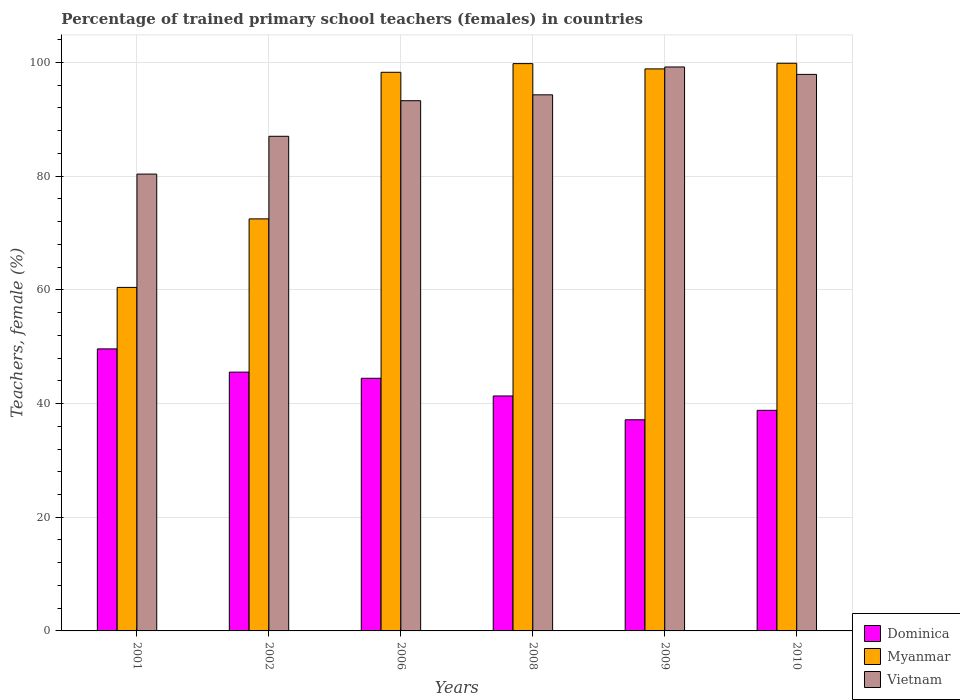How many bars are there on the 3rd tick from the right?
Your response must be concise. 3. What is the label of the 1st group of bars from the left?
Make the answer very short. 2001. What is the percentage of trained primary school teachers (females) in Myanmar in 2001?
Your answer should be compact. 60.43. Across all years, what is the maximum percentage of trained primary school teachers (females) in Myanmar?
Keep it short and to the point. 99.86. Across all years, what is the minimum percentage of trained primary school teachers (females) in Dominica?
Your answer should be compact. 37.14. In which year was the percentage of trained primary school teachers (females) in Dominica minimum?
Make the answer very short. 2009. What is the total percentage of trained primary school teachers (females) in Dominica in the graph?
Your answer should be compact. 256.87. What is the difference between the percentage of trained primary school teachers (females) in Myanmar in 2001 and that in 2006?
Ensure brevity in your answer.  -37.84. What is the difference between the percentage of trained primary school teachers (females) in Myanmar in 2010 and the percentage of trained primary school teachers (females) in Dominica in 2006?
Your answer should be very brief. 55.42. What is the average percentage of trained primary school teachers (females) in Myanmar per year?
Your answer should be compact. 88.29. In the year 2009, what is the difference between the percentage of trained primary school teachers (females) in Dominica and percentage of trained primary school teachers (females) in Vietnam?
Keep it short and to the point. -62.06. In how many years, is the percentage of trained primary school teachers (females) in Vietnam greater than 96 %?
Offer a very short reply. 2. What is the ratio of the percentage of trained primary school teachers (females) in Vietnam in 2001 to that in 2010?
Your response must be concise. 0.82. Is the difference between the percentage of trained primary school teachers (females) in Dominica in 2002 and 2008 greater than the difference between the percentage of trained primary school teachers (females) in Vietnam in 2002 and 2008?
Offer a terse response. Yes. What is the difference between the highest and the second highest percentage of trained primary school teachers (females) in Vietnam?
Your response must be concise. 1.31. What is the difference between the highest and the lowest percentage of trained primary school teachers (females) in Myanmar?
Ensure brevity in your answer.  39.43. Is the sum of the percentage of trained primary school teachers (females) in Myanmar in 2001 and 2006 greater than the maximum percentage of trained primary school teachers (females) in Vietnam across all years?
Offer a terse response. Yes. What does the 2nd bar from the left in 2006 represents?
Offer a terse response. Myanmar. What does the 1st bar from the right in 2009 represents?
Provide a short and direct response. Vietnam. Is it the case that in every year, the sum of the percentage of trained primary school teachers (females) in Myanmar and percentage of trained primary school teachers (females) in Dominica is greater than the percentage of trained primary school teachers (females) in Vietnam?
Give a very brief answer. Yes. How many bars are there?
Keep it short and to the point. 18. Does the graph contain any zero values?
Offer a very short reply. No. Where does the legend appear in the graph?
Ensure brevity in your answer.  Bottom right. How many legend labels are there?
Offer a terse response. 3. What is the title of the graph?
Your answer should be compact. Percentage of trained primary school teachers (females) in countries. Does "Maldives" appear as one of the legend labels in the graph?
Your answer should be very brief. No. What is the label or title of the X-axis?
Your answer should be very brief. Years. What is the label or title of the Y-axis?
Offer a very short reply. Teachers, female (%). What is the Teachers, female (%) in Dominica in 2001?
Offer a terse response. 49.61. What is the Teachers, female (%) of Myanmar in 2001?
Keep it short and to the point. 60.43. What is the Teachers, female (%) of Vietnam in 2001?
Your answer should be very brief. 80.37. What is the Teachers, female (%) in Dominica in 2002?
Ensure brevity in your answer.  45.53. What is the Teachers, female (%) in Myanmar in 2002?
Your answer should be compact. 72.48. What is the Teachers, female (%) of Vietnam in 2002?
Provide a succinct answer. 87.01. What is the Teachers, female (%) of Dominica in 2006?
Provide a short and direct response. 44.44. What is the Teachers, female (%) of Myanmar in 2006?
Offer a very short reply. 98.27. What is the Teachers, female (%) in Vietnam in 2006?
Your response must be concise. 93.27. What is the Teachers, female (%) of Dominica in 2008?
Offer a very short reply. 41.33. What is the Teachers, female (%) of Myanmar in 2008?
Give a very brief answer. 99.8. What is the Teachers, female (%) in Vietnam in 2008?
Make the answer very short. 94.31. What is the Teachers, female (%) in Dominica in 2009?
Keep it short and to the point. 37.14. What is the Teachers, female (%) in Myanmar in 2009?
Provide a short and direct response. 98.87. What is the Teachers, female (%) in Vietnam in 2009?
Provide a short and direct response. 99.21. What is the Teachers, female (%) in Dominica in 2010?
Provide a succinct answer. 38.81. What is the Teachers, female (%) of Myanmar in 2010?
Offer a terse response. 99.86. What is the Teachers, female (%) of Vietnam in 2010?
Provide a short and direct response. 97.9. Across all years, what is the maximum Teachers, female (%) in Dominica?
Your answer should be compact. 49.61. Across all years, what is the maximum Teachers, female (%) of Myanmar?
Your response must be concise. 99.86. Across all years, what is the maximum Teachers, female (%) in Vietnam?
Your response must be concise. 99.21. Across all years, what is the minimum Teachers, female (%) in Dominica?
Keep it short and to the point. 37.14. Across all years, what is the minimum Teachers, female (%) in Myanmar?
Provide a short and direct response. 60.43. Across all years, what is the minimum Teachers, female (%) in Vietnam?
Provide a succinct answer. 80.37. What is the total Teachers, female (%) in Dominica in the graph?
Keep it short and to the point. 256.87. What is the total Teachers, female (%) of Myanmar in the graph?
Keep it short and to the point. 529.71. What is the total Teachers, female (%) of Vietnam in the graph?
Ensure brevity in your answer.  552.06. What is the difference between the Teachers, female (%) in Dominica in 2001 and that in 2002?
Your response must be concise. 4.08. What is the difference between the Teachers, female (%) in Myanmar in 2001 and that in 2002?
Offer a terse response. -12.05. What is the difference between the Teachers, female (%) of Vietnam in 2001 and that in 2002?
Offer a very short reply. -6.65. What is the difference between the Teachers, female (%) in Dominica in 2001 and that in 2006?
Provide a short and direct response. 5.17. What is the difference between the Teachers, female (%) in Myanmar in 2001 and that in 2006?
Your answer should be compact. -37.84. What is the difference between the Teachers, female (%) in Vietnam in 2001 and that in 2006?
Give a very brief answer. -12.91. What is the difference between the Teachers, female (%) of Dominica in 2001 and that in 2008?
Keep it short and to the point. 8.28. What is the difference between the Teachers, female (%) of Myanmar in 2001 and that in 2008?
Make the answer very short. -39.37. What is the difference between the Teachers, female (%) in Vietnam in 2001 and that in 2008?
Give a very brief answer. -13.94. What is the difference between the Teachers, female (%) in Dominica in 2001 and that in 2009?
Ensure brevity in your answer.  12.47. What is the difference between the Teachers, female (%) in Myanmar in 2001 and that in 2009?
Your response must be concise. -38.44. What is the difference between the Teachers, female (%) of Vietnam in 2001 and that in 2009?
Give a very brief answer. -18.84. What is the difference between the Teachers, female (%) of Dominica in 2001 and that in 2010?
Give a very brief answer. 10.81. What is the difference between the Teachers, female (%) of Myanmar in 2001 and that in 2010?
Make the answer very short. -39.43. What is the difference between the Teachers, female (%) of Vietnam in 2001 and that in 2010?
Your response must be concise. -17.53. What is the difference between the Teachers, female (%) in Dominica in 2002 and that in 2006?
Your response must be concise. 1.08. What is the difference between the Teachers, female (%) of Myanmar in 2002 and that in 2006?
Give a very brief answer. -25.79. What is the difference between the Teachers, female (%) of Vietnam in 2002 and that in 2006?
Your response must be concise. -6.26. What is the difference between the Teachers, female (%) in Dominica in 2002 and that in 2008?
Ensure brevity in your answer.  4.2. What is the difference between the Teachers, female (%) of Myanmar in 2002 and that in 2008?
Offer a terse response. -27.31. What is the difference between the Teachers, female (%) of Vietnam in 2002 and that in 2008?
Give a very brief answer. -7.3. What is the difference between the Teachers, female (%) in Dominica in 2002 and that in 2009?
Provide a short and direct response. 8.39. What is the difference between the Teachers, female (%) in Myanmar in 2002 and that in 2009?
Ensure brevity in your answer.  -26.38. What is the difference between the Teachers, female (%) in Vietnam in 2002 and that in 2009?
Your answer should be very brief. -12.19. What is the difference between the Teachers, female (%) of Dominica in 2002 and that in 2010?
Your answer should be compact. 6.72. What is the difference between the Teachers, female (%) in Myanmar in 2002 and that in 2010?
Your answer should be very brief. -27.38. What is the difference between the Teachers, female (%) of Vietnam in 2002 and that in 2010?
Your response must be concise. -10.89. What is the difference between the Teachers, female (%) in Dominica in 2006 and that in 2008?
Offer a terse response. 3.11. What is the difference between the Teachers, female (%) of Myanmar in 2006 and that in 2008?
Your answer should be very brief. -1.52. What is the difference between the Teachers, female (%) of Vietnam in 2006 and that in 2008?
Your answer should be compact. -1.04. What is the difference between the Teachers, female (%) of Dominica in 2006 and that in 2009?
Make the answer very short. 7.3. What is the difference between the Teachers, female (%) of Myanmar in 2006 and that in 2009?
Make the answer very short. -0.6. What is the difference between the Teachers, female (%) of Vietnam in 2006 and that in 2009?
Offer a very short reply. -5.93. What is the difference between the Teachers, female (%) in Dominica in 2006 and that in 2010?
Offer a terse response. 5.64. What is the difference between the Teachers, female (%) in Myanmar in 2006 and that in 2010?
Your answer should be compact. -1.59. What is the difference between the Teachers, female (%) in Vietnam in 2006 and that in 2010?
Your response must be concise. -4.63. What is the difference between the Teachers, female (%) in Dominica in 2008 and that in 2009?
Offer a very short reply. 4.19. What is the difference between the Teachers, female (%) of Myanmar in 2008 and that in 2009?
Your answer should be compact. 0.93. What is the difference between the Teachers, female (%) of Vietnam in 2008 and that in 2009?
Offer a terse response. -4.9. What is the difference between the Teachers, female (%) of Dominica in 2008 and that in 2010?
Ensure brevity in your answer.  2.53. What is the difference between the Teachers, female (%) of Myanmar in 2008 and that in 2010?
Your response must be concise. -0.06. What is the difference between the Teachers, female (%) in Vietnam in 2008 and that in 2010?
Give a very brief answer. -3.59. What is the difference between the Teachers, female (%) in Dominica in 2009 and that in 2010?
Your answer should be very brief. -1.66. What is the difference between the Teachers, female (%) of Myanmar in 2009 and that in 2010?
Provide a short and direct response. -0.99. What is the difference between the Teachers, female (%) in Vietnam in 2009 and that in 2010?
Ensure brevity in your answer.  1.31. What is the difference between the Teachers, female (%) of Dominica in 2001 and the Teachers, female (%) of Myanmar in 2002?
Offer a very short reply. -22.87. What is the difference between the Teachers, female (%) in Dominica in 2001 and the Teachers, female (%) in Vietnam in 2002?
Keep it short and to the point. -37.4. What is the difference between the Teachers, female (%) in Myanmar in 2001 and the Teachers, female (%) in Vietnam in 2002?
Keep it short and to the point. -26.58. What is the difference between the Teachers, female (%) in Dominica in 2001 and the Teachers, female (%) in Myanmar in 2006?
Give a very brief answer. -48.66. What is the difference between the Teachers, female (%) of Dominica in 2001 and the Teachers, female (%) of Vietnam in 2006?
Keep it short and to the point. -43.66. What is the difference between the Teachers, female (%) of Myanmar in 2001 and the Teachers, female (%) of Vietnam in 2006?
Offer a terse response. -32.84. What is the difference between the Teachers, female (%) of Dominica in 2001 and the Teachers, female (%) of Myanmar in 2008?
Your answer should be very brief. -50.18. What is the difference between the Teachers, female (%) in Dominica in 2001 and the Teachers, female (%) in Vietnam in 2008?
Provide a short and direct response. -44.7. What is the difference between the Teachers, female (%) of Myanmar in 2001 and the Teachers, female (%) of Vietnam in 2008?
Give a very brief answer. -33.88. What is the difference between the Teachers, female (%) of Dominica in 2001 and the Teachers, female (%) of Myanmar in 2009?
Your answer should be compact. -49.26. What is the difference between the Teachers, female (%) in Dominica in 2001 and the Teachers, female (%) in Vietnam in 2009?
Your answer should be very brief. -49.59. What is the difference between the Teachers, female (%) of Myanmar in 2001 and the Teachers, female (%) of Vietnam in 2009?
Provide a succinct answer. -38.78. What is the difference between the Teachers, female (%) in Dominica in 2001 and the Teachers, female (%) in Myanmar in 2010?
Ensure brevity in your answer.  -50.25. What is the difference between the Teachers, female (%) of Dominica in 2001 and the Teachers, female (%) of Vietnam in 2010?
Your answer should be very brief. -48.29. What is the difference between the Teachers, female (%) in Myanmar in 2001 and the Teachers, female (%) in Vietnam in 2010?
Offer a terse response. -37.47. What is the difference between the Teachers, female (%) in Dominica in 2002 and the Teachers, female (%) in Myanmar in 2006?
Provide a succinct answer. -52.74. What is the difference between the Teachers, female (%) in Dominica in 2002 and the Teachers, female (%) in Vietnam in 2006?
Your answer should be compact. -47.74. What is the difference between the Teachers, female (%) in Myanmar in 2002 and the Teachers, female (%) in Vietnam in 2006?
Your response must be concise. -20.79. What is the difference between the Teachers, female (%) in Dominica in 2002 and the Teachers, female (%) in Myanmar in 2008?
Provide a short and direct response. -54.27. What is the difference between the Teachers, female (%) of Dominica in 2002 and the Teachers, female (%) of Vietnam in 2008?
Your response must be concise. -48.78. What is the difference between the Teachers, female (%) in Myanmar in 2002 and the Teachers, female (%) in Vietnam in 2008?
Keep it short and to the point. -21.82. What is the difference between the Teachers, female (%) of Dominica in 2002 and the Teachers, female (%) of Myanmar in 2009?
Offer a terse response. -53.34. What is the difference between the Teachers, female (%) in Dominica in 2002 and the Teachers, female (%) in Vietnam in 2009?
Your answer should be very brief. -53.68. What is the difference between the Teachers, female (%) in Myanmar in 2002 and the Teachers, female (%) in Vietnam in 2009?
Ensure brevity in your answer.  -26.72. What is the difference between the Teachers, female (%) of Dominica in 2002 and the Teachers, female (%) of Myanmar in 2010?
Ensure brevity in your answer.  -54.33. What is the difference between the Teachers, female (%) in Dominica in 2002 and the Teachers, female (%) in Vietnam in 2010?
Provide a succinct answer. -52.37. What is the difference between the Teachers, female (%) of Myanmar in 2002 and the Teachers, female (%) of Vietnam in 2010?
Give a very brief answer. -25.41. What is the difference between the Teachers, female (%) in Dominica in 2006 and the Teachers, female (%) in Myanmar in 2008?
Your answer should be very brief. -55.35. What is the difference between the Teachers, female (%) of Dominica in 2006 and the Teachers, female (%) of Vietnam in 2008?
Ensure brevity in your answer.  -49.86. What is the difference between the Teachers, female (%) of Myanmar in 2006 and the Teachers, female (%) of Vietnam in 2008?
Make the answer very short. 3.96. What is the difference between the Teachers, female (%) in Dominica in 2006 and the Teachers, female (%) in Myanmar in 2009?
Your response must be concise. -54.42. What is the difference between the Teachers, female (%) of Dominica in 2006 and the Teachers, female (%) of Vietnam in 2009?
Offer a very short reply. -54.76. What is the difference between the Teachers, female (%) of Myanmar in 2006 and the Teachers, female (%) of Vietnam in 2009?
Your answer should be compact. -0.93. What is the difference between the Teachers, female (%) of Dominica in 2006 and the Teachers, female (%) of Myanmar in 2010?
Your answer should be compact. -55.42. What is the difference between the Teachers, female (%) of Dominica in 2006 and the Teachers, female (%) of Vietnam in 2010?
Make the answer very short. -53.45. What is the difference between the Teachers, female (%) of Myanmar in 2006 and the Teachers, female (%) of Vietnam in 2010?
Give a very brief answer. 0.37. What is the difference between the Teachers, female (%) in Dominica in 2008 and the Teachers, female (%) in Myanmar in 2009?
Your answer should be very brief. -57.54. What is the difference between the Teachers, female (%) of Dominica in 2008 and the Teachers, female (%) of Vietnam in 2009?
Provide a short and direct response. -57.87. What is the difference between the Teachers, female (%) of Myanmar in 2008 and the Teachers, female (%) of Vietnam in 2009?
Make the answer very short. 0.59. What is the difference between the Teachers, female (%) of Dominica in 2008 and the Teachers, female (%) of Myanmar in 2010?
Offer a terse response. -58.53. What is the difference between the Teachers, female (%) of Dominica in 2008 and the Teachers, female (%) of Vietnam in 2010?
Offer a very short reply. -56.57. What is the difference between the Teachers, female (%) of Myanmar in 2008 and the Teachers, female (%) of Vietnam in 2010?
Provide a succinct answer. 1.9. What is the difference between the Teachers, female (%) in Dominica in 2009 and the Teachers, female (%) in Myanmar in 2010?
Provide a short and direct response. -62.72. What is the difference between the Teachers, female (%) in Dominica in 2009 and the Teachers, female (%) in Vietnam in 2010?
Keep it short and to the point. -60.76. What is the difference between the Teachers, female (%) in Myanmar in 2009 and the Teachers, female (%) in Vietnam in 2010?
Your answer should be compact. 0.97. What is the average Teachers, female (%) of Dominica per year?
Your response must be concise. 42.81. What is the average Teachers, female (%) in Myanmar per year?
Your answer should be compact. 88.29. What is the average Teachers, female (%) of Vietnam per year?
Your response must be concise. 92.01. In the year 2001, what is the difference between the Teachers, female (%) in Dominica and Teachers, female (%) in Myanmar?
Offer a terse response. -10.82. In the year 2001, what is the difference between the Teachers, female (%) in Dominica and Teachers, female (%) in Vietnam?
Provide a short and direct response. -30.75. In the year 2001, what is the difference between the Teachers, female (%) of Myanmar and Teachers, female (%) of Vietnam?
Your response must be concise. -19.94. In the year 2002, what is the difference between the Teachers, female (%) of Dominica and Teachers, female (%) of Myanmar?
Keep it short and to the point. -26.96. In the year 2002, what is the difference between the Teachers, female (%) in Dominica and Teachers, female (%) in Vietnam?
Provide a succinct answer. -41.48. In the year 2002, what is the difference between the Teachers, female (%) in Myanmar and Teachers, female (%) in Vietnam?
Offer a terse response. -14.53. In the year 2006, what is the difference between the Teachers, female (%) of Dominica and Teachers, female (%) of Myanmar?
Ensure brevity in your answer.  -53.83. In the year 2006, what is the difference between the Teachers, female (%) of Dominica and Teachers, female (%) of Vietnam?
Make the answer very short. -48.83. In the year 2006, what is the difference between the Teachers, female (%) in Myanmar and Teachers, female (%) in Vietnam?
Ensure brevity in your answer.  5. In the year 2008, what is the difference between the Teachers, female (%) of Dominica and Teachers, female (%) of Myanmar?
Offer a very short reply. -58.46. In the year 2008, what is the difference between the Teachers, female (%) of Dominica and Teachers, female (%) of Vietnam?
Your answer should be compact. -52.97. In the year 2008, what is the difference between the Teachers, female (%) in Myanmar and Teachers, female (%) in Vietnam?
Provide a succinct answer. 5.49. In the year 2009, what is the difference between the Teachers, female (%) of Dominica and Teachers, female (%) of Myanmar?
Ensure brevity in your answer.  -61.73. In the year 2009, what is the difference between the Teachers, female (%) of Dominica and Teachers, female (%) of Vietnam?
Give a very brief answer. -62.06. In the year 2009, what is the difference between the Teachers, female (%) of Myanmar and Teachers, female (%) of Vietnam?
Offer a terse response. -0.34. In the year 2010, what is the difference between the Teachers, female (%) of Dominica and Teachers, female (%) of Myanmar?
Give a very brief answer. -61.05. In the year 2010, what is the difference between the Teachers, female (%) in Dominica and Teachers, female (%) in Vietnam?
Your answer should be compact. -59.09. In the year 2010, what is the difference between the Teachers, female (%) in Myanmar and Teachers, female (%) in Vietnam?
Offer a terse response. 1.96. What is the ratio of the Teachers, female (%) in Dominica in 2001 to that in 2002?
Your response must be concise. 1.09. What is the ratio of the Teachers, female (%) of Myanmar in 2001 to that in 2002?
Your response must be concise. 0.83. What is the ratio of the Teachers, female (%) of Vietnam in 2001 to that in 2002?
Give a very brief answer. 0.92. What is the ratio of the Teachers, female (%) in Dominica in 2001 to that in 2006?
Your answer should be compact. 1.12. What is the ratio of the Teachers, female (%) in Myanmar in 2001 to that in 2006?
Offer a terse response. 0.61. What is the ratio of the Teachers, female (%) in Vietnam in 2001 to that in 2006?
Make the answer very short. 0.86. What is the ratio of the Teachers, female (%) of Dominica in 2001 to that in 2008?
Provide a succinct answer. 1.2. What is the ratio of the Teachers, female (%) in Myanmar in 2001 to that in 2008?
Ensure brevity in your answer.  0.61. What is the ratio of the Teachers, female (%) in Vietnam in 2001 to that in 2008?
Provide a succinct answer. 0.85. What is the ratio of the Teachers, female (%) in Dominica in 2001 to that in 2009?
Your answer should be very brief. 1.34. What is the ratio of the Teachers, female (%) of Myanmar in 2001 to that in 2009?
Your answer should be compact. 0.61. What is the ratio of the Teachers, female (%) of Vietnam in 2001 to that in 2009?
Ensure brevity in your answer.  0.81. What is the ratio of the Teachers, female (%) in Dominica in 2001 to that in 2010?
Provide a succinct answer. 1.28. What is the ratio of the Teachers, female (%) in Myanmar in 2001 to that in 2010?
Your response must be concise. 0.61. What is the ratio of the Teachers, female (%) in Vietnam in 2001 to that in 2010?
Provide a short and direct response. 0.82. What is the ratio of the Teachers, female (%) in Dominica in 2002 to that in 2006?
Provide a succinct answer. 1.02. What is the ratio of the Teachers, female (%) in Myanmar in 2002 to that in 2006?
Your response must be concise. 0.74. What is the ratio of the Teachers, female (%) in Vietnam in 2002 to that in 2006?
Make the answer very short. 0.93. What is the ratio of the Teachers, female (%) in Dominica in 2002 to that in 2008?
Ensure brevity in your answer.  1.1. What is the ratio of the Teachers, female (%) of Myanmar in 2002 to that in 2008?
Offer a very short reply. 0.73. What is the ratio of the Teachers, female (%) in Vietnam in 2002 to that in 2008?
Ensure brevity in your answer.  0.92. What is the ratio of the Teachers, female (%) of Dominica in 2002 to that in 2009?
Make the answer very short. 1.23. What is the ratio of the Teachers, female (%) in Myanmar in 2002 to that in 2009?
Ensure brevity in your answer.  0.73. What is the ratio of the Teachers, female (%) in Vietnam in 2002 to that in 2009?
Provide a short and direct response. 0.88. What is the ratio of the Teachers, female (%) of Dominica in 2002 to that in 2010?
Keep it short and to the point. 1.17. What is the ratio of the Teachers, female (%) of Myanmar in 2002 to that in 2010?
Ensure brevity in your answer.  0.73. What is the ratio of the Teachers, female (%) of Vietnam in 2002 to that in 2010?
Your answer should be very brief. 0.89. What is the ratio of the Teachers, female (%) in Dominica in 2006 to that in 2008?
Offer a very short reply. 1.08. What is the ratio of the Teachers, female (%) in Myanmar in 2006 to that in 2008?
Your answer should be very brief. 0.98. What is the ratio of the Teachers, female (%) of Dominica in 2006 to that in 2009?
Your response must be concise. 1.2. What is the ratio of the Teachers, female (%) of Vietnam in 2006 to that in 2009?
Provide a short and direct response. 0.94. What is the ratio of the Teachers, female (%) in Dominica in 2006 to that in 2010?
Keep it short and to the point. 1.15. What is the ratio of the Teachers, female (%) in Myanmar in 2006 to that in 2010?
Give a very brief answer. 0.98. What is the ratio of the Teachers, female (%) of Vietnam in 2006 to that in 2010?
Your answer should be very brief. 0.95. What is the ratio of the Teachers, female (%) in Dominica in 2008 to that in 2009?
Your answer should be compact. 1.11. What is the ratio of the Teachers, female (%) of Myanmar in 2008 to that in 2009?
Your answer should be compact. 1.01. What is the ratio of the Teachers, female (%) of Vietnam in 2008 to that in 2009?
Offer a terse response. 0.95. What is the ratio of the Teachers, female (%) in Dominica in 2008 to that in 2010?
Provide a short and direct response. 1.07. What is the ratio of the Teachers, female (%) in Myanmar in 2008 to that in 2010?
Offer a very short reply. 1. What is the ratio of the Teachers, female (%) of Vietnam in 2008 to that in 2010?
Your answer should be very brief. 0.96. What is the ratio of the Teachers, female (%) in Dominica in 2009 to that in 2010?
Give a very brief answer. 0.96. What is the ratio of the Teachers, female (%) of Myanmar in 2009 to that in 2010?
Your answer should be very brief. 0.99. What is the ratio of the Teachers, female (%) in Vietnam in 2009 to that in 2010?
Ensure brevity in your answer.  1.01. What is the difference between the highest and the second highest Teachers, female (%) in Dominica?
Your response must be concise. 4.08. What is the difference between the highest and the second highest Teachers, female (%) of Myanmar?
Ensure brevity in your answer.  0.06. What is the difference between the highest and the second highest Teachers, female (%) in Vietnam?
Give a very brief answer. 1.31. What is the difference between the highest and the lowest Teachers, female (%) of Dominica?
Give a very brief answer. 12.47. What is the difference between the highest and the lowest Teachers, female (%) in Myanmar?
Give a very brief answer. 39.43. What is the difference between the highest and the lowest Teachers, female (%) in Vietnam?
Provide a short and direct response. 18.84. 